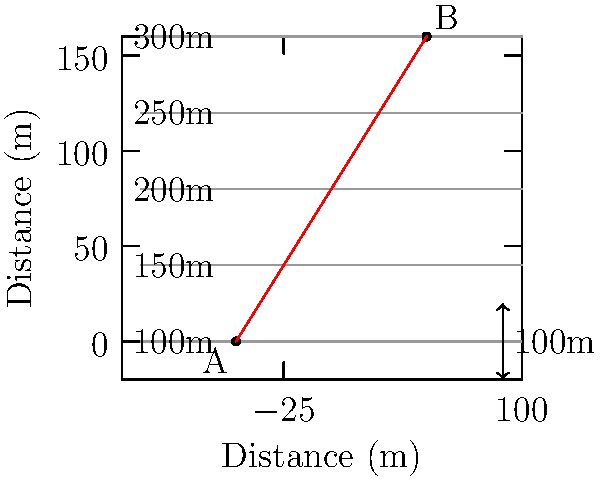As a farmer, you're planning to install an irrigation system on your sloped terrain. Using the topographic map provided, calculate the slope between points A and B. The horizontal distance between A and B is 100 meters. What is the average slope as a percentage? To calculate the slope between points A and B, we need to follow these steps:

1. Determine the elevation change:
   Point A is at 100m elevation
   Point B is at 300m elevation
   Elevation change = 300m - 100m = 200m

2. Calculate the horizontal distance:
   Given in the question as 100 meters

3. Calculate the slope using the formula:
   $\text{Slope} = \frac{\text{Rise}}{\text{Run}} = \frac{\text{Elevation change}}{\text{Horizontal distance}}$

   $\text{Slope} = \frac{200\text{ m}}{100\text{ m}} = 2$

4. Convert the slope to a percentage:
   Percentage slope = Slope × 100%
   $\text{Percentage slope} = 2 \times 100\% = 200\%$

Therefore, the average slope between points A and B is 200%.
Answer: 200% 